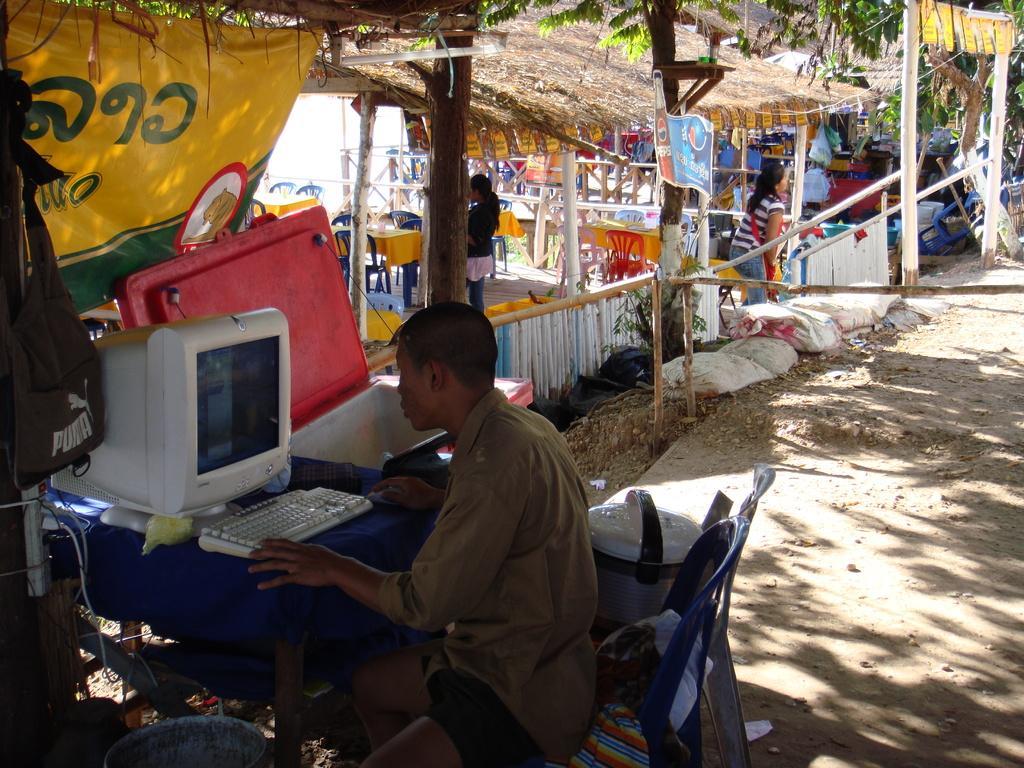In one or two sentences, can you explain what this image depicts? In this image I can see a man is sitting on a chair. I can also see a table and on it I can see a keyboard and a monitor. I can also see few trees, few boards, number of chairs, tables, few people and on these boards I can see something is written. I can also see few other things over here. 